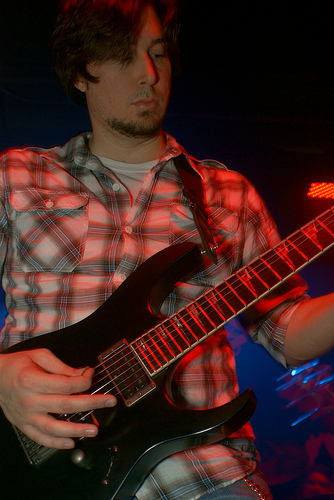<image>
Is the man on the guitar? Yes. Looking at the image, I can see the man is positioned on top of the guitar, with the guitar providing support. 